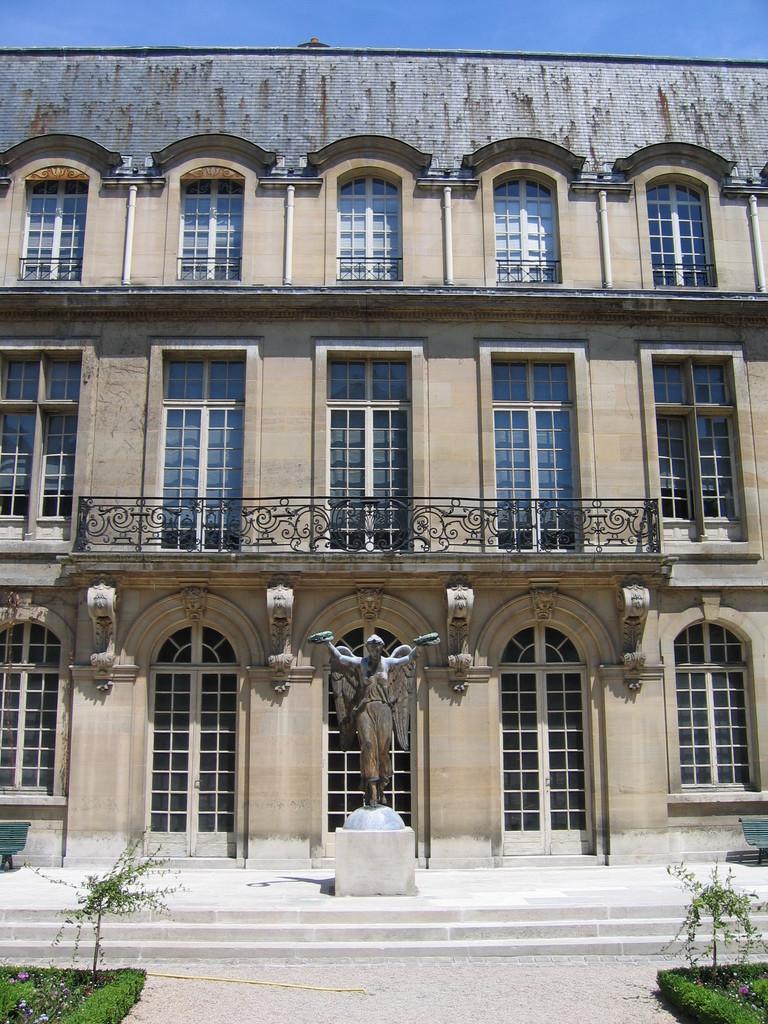Describe this image in one or two sentences. In the picture I can see a building which has few glass windows on it and there is a statue in front of it and there are few plants on either sides of it. 